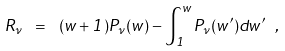<formula> <loc_0><loc_0><loc_500><loc_500>R _ { \nu } \ = \ ( w + 1 ) P _ { \nu } ( w ) - \int _ { 1 } ^ { w } P _ { \nu } ( w ^ { \prime } ) d w ^ { \prime } \ ,</formula> 